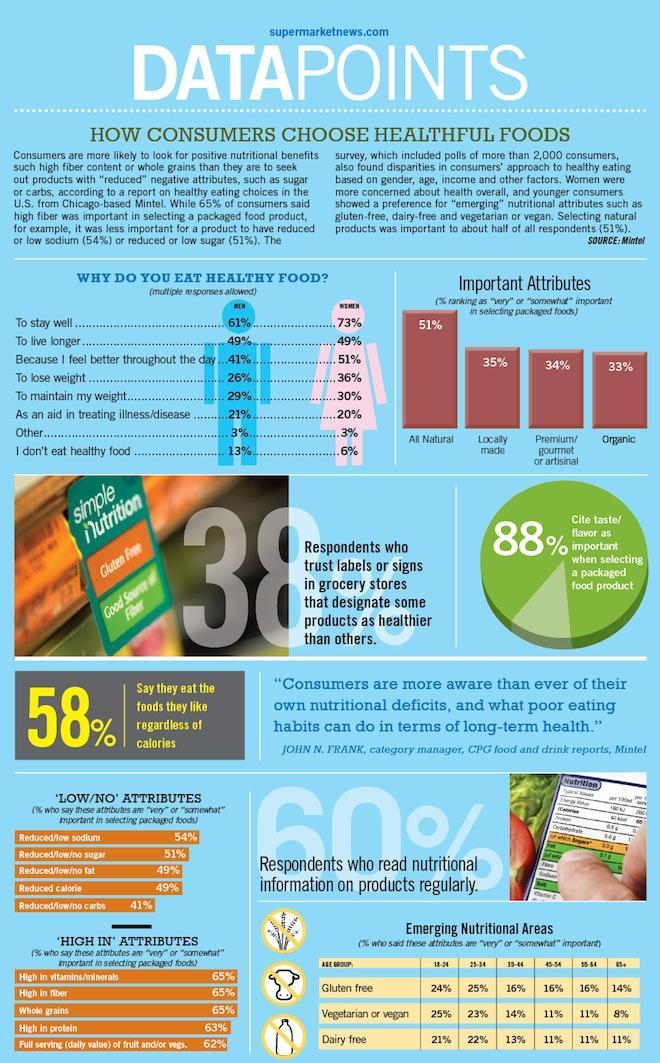Which is the second most important attribute while selecting packaged foods?
Answer the question with a short phrase. Locally made What percent do not cite taste /flavour as important? 12% What percent of people do not read nutritional information on products regularly? 40% 